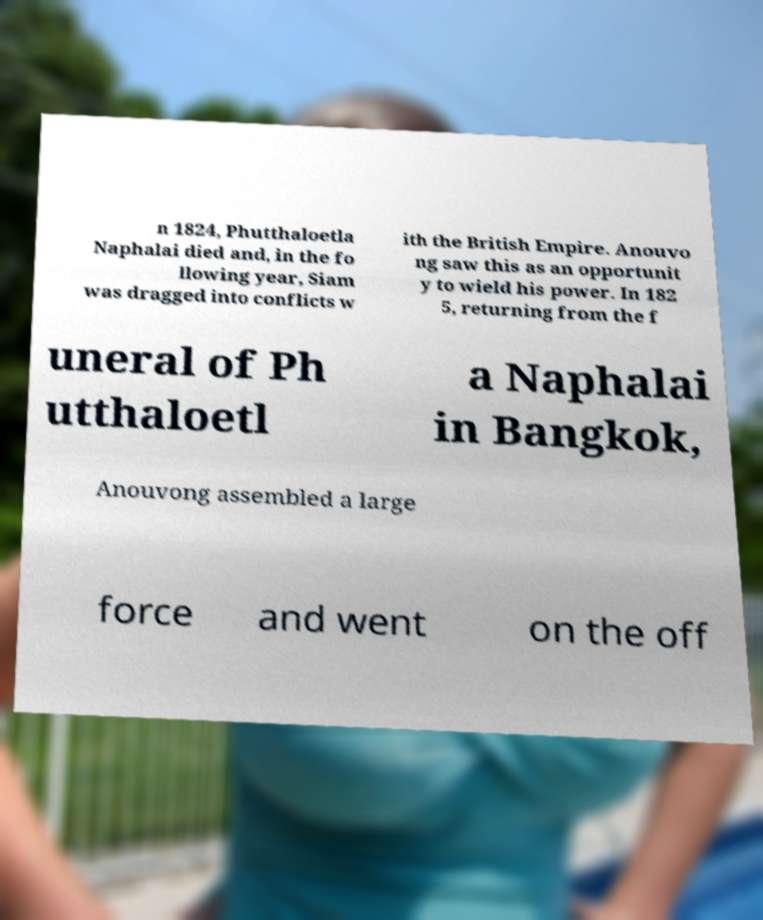I need the written content from this picture converted into text. Can you do that? n 1824, Phutthaloetla Naphalai died and, in the fo llowing year, Siam was dragged into conflicts w ith the British Empire. Anouvo ng saw this as an opportunit y to wield his power. In 182 5, returning from the f uneral of Ph utthaloetl a Naphalai in Bangkok, Anouvong assembled a large force and went on the off 